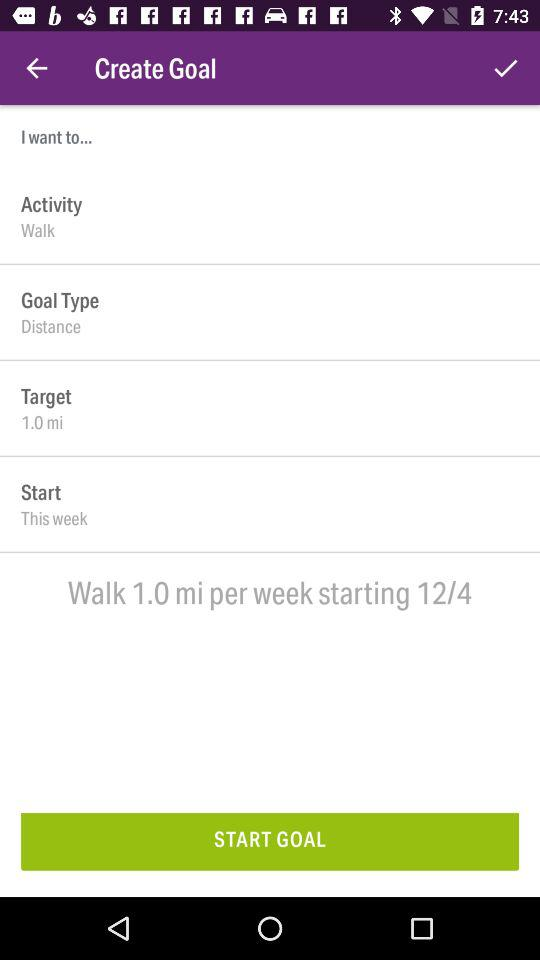What is the set target? The set target is 1.0 miles. 